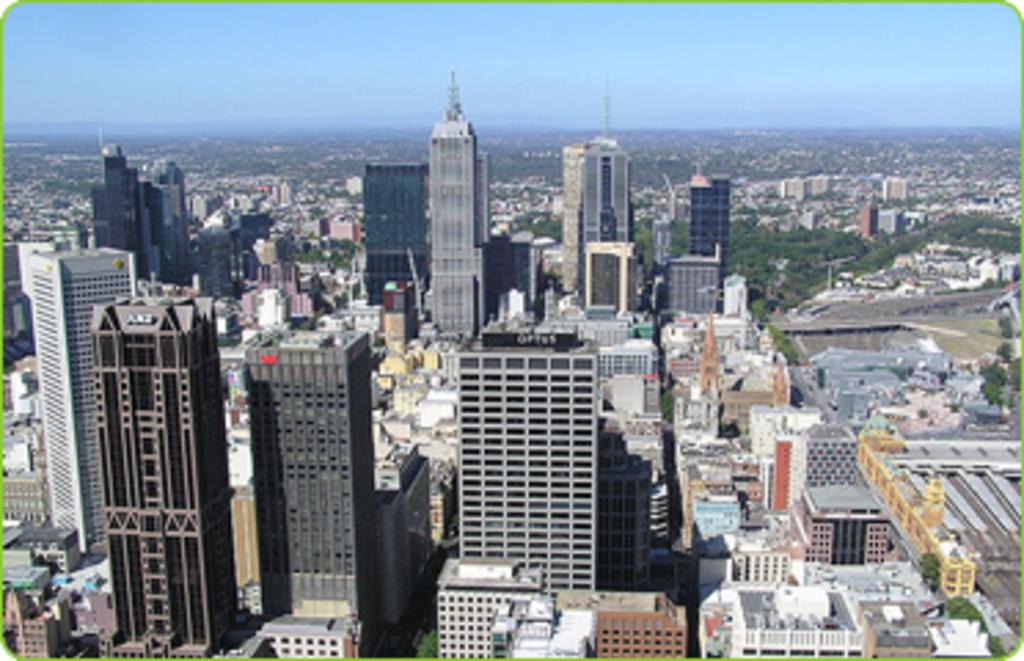What type of image is being described? The image is an edited picture. What structures can be seen in the image? There are buildings in the image. What type of vegetation is present in the image? There are trees in the image. What is visible in the background of the image? The sky is visible in the background of the image. Can you see the thumb of the person who edited the image? There is no indication of a thumb or any person involved in editing the image in the picture itself. 